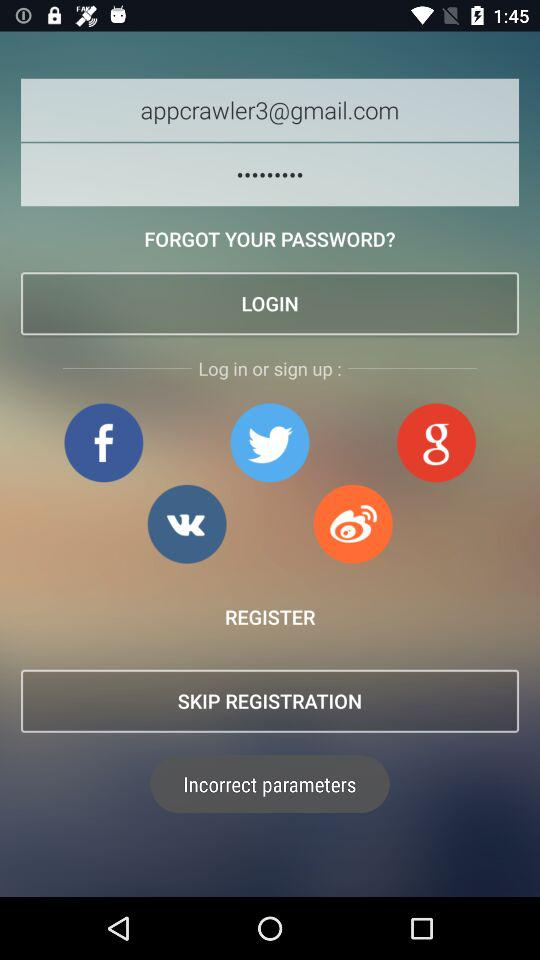What is the email address? The email address is appcrawler3@gmail.com. 